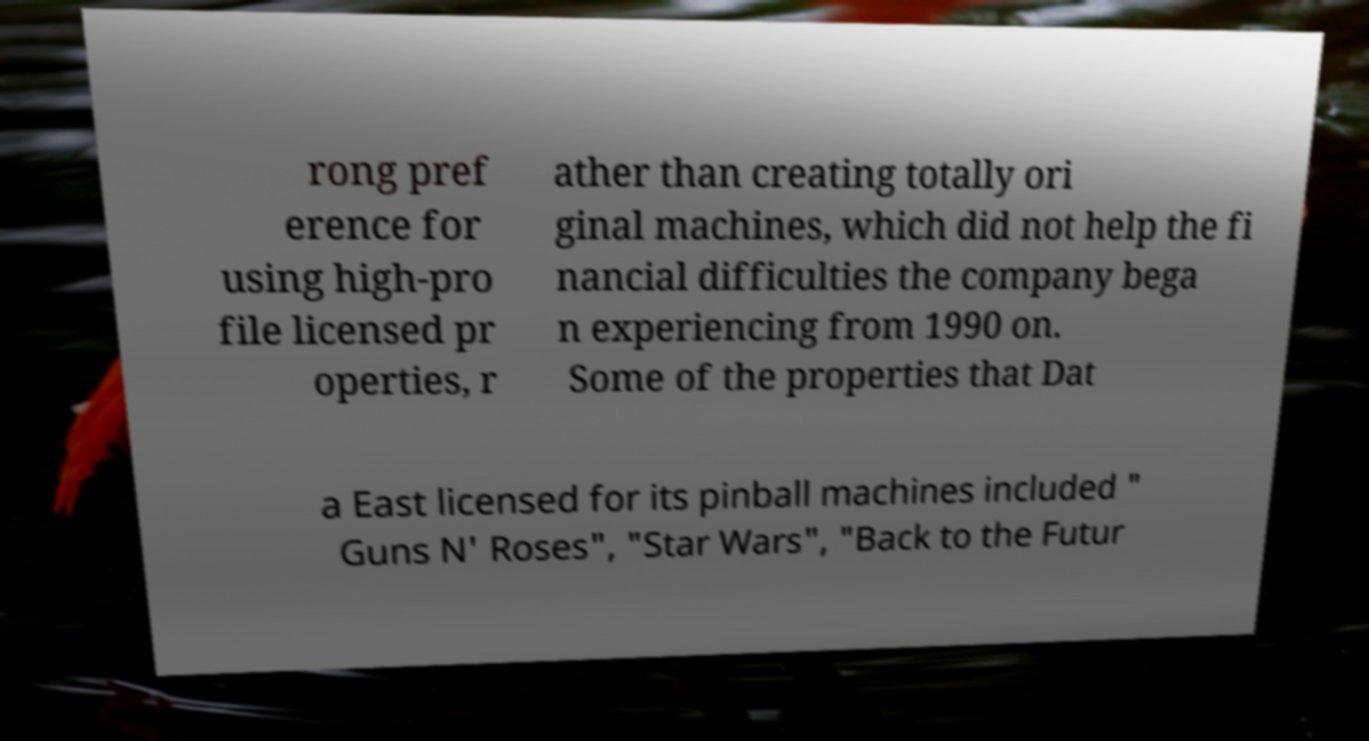For documentation purposes, I need the text within this image transcribed. Could you provide that? rong pref erence for using high-pro file licensed pr operties, r ather than creating totally ori ginal machines, which did not help the fi nancial difficulties the company bega n experiencing from 1990 on. Some of the properties that Dat a East licensed for its pinball machines included " Guns N' Roses", "Star Wars", "Back to the Futur 